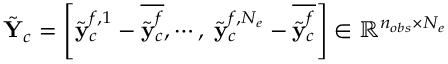Convert formula to latex. <formula><loc_0><loc_0><loc_500><loc_500>\tilde { Y } _ { c } = \left [ { \tilde { y } } _ { c } ^ { f , 1 } - \overline { { \tilde { y } _ { c } ^ { f } } } , \cdots , \, \tilde { y } _ { c } ^ { f , N _ { e } } - \overline { { \tilde { y } _ { c } ^ { f } } } \right ] \in \mathbb { R } ^ { n _ { o b s } \times N _ { e } }</formula> 